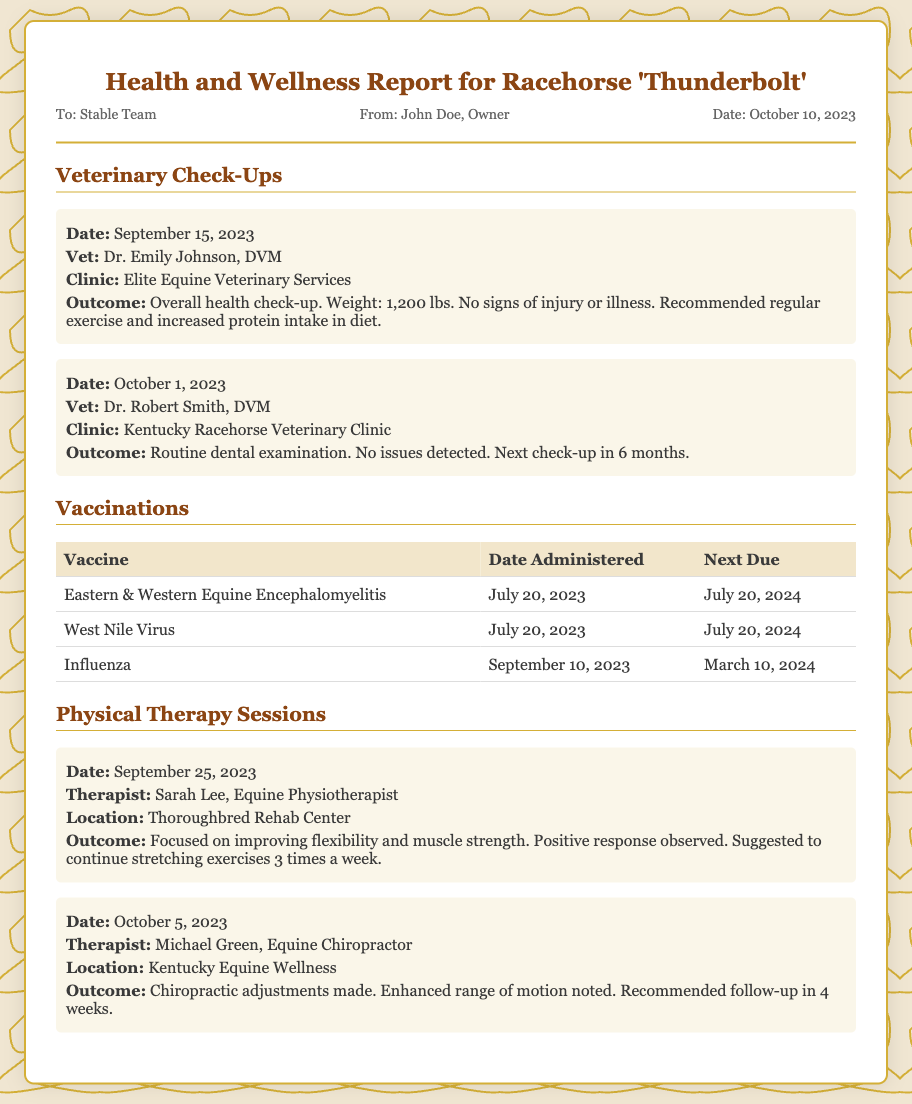What is the name of the racehorse? The document is focused on the health and wellness report for racehorse 'Thunderbolt'.
Answer: Thunderbolt Who is the veterinarian for the September 15, 2023 check-up? The document states that Dr. Emily Johnson, DVM conducted the check-up on September 15, 2023.
Answer: Dr. Emily Johnson What is the weight of Thunderbolt according to the check-up on September 15, 2023? The document mentions Thunderbolt's weight during the check-up was 1,200 lbs.
Answer: 1,200 lbs When is the next dental check-up scheduled? According to the report, the next dental check-up will be in 6 months after October 1, 2023.
Answer: April 1, 2024 How many vaccines were administered on July 20, 2023? The document lists two vaccines administered on that date: Eastern & Western Equine Encephalomyelitis and West Nile Virus.
Answer: Two What was the outcome of the physical therapy session on September 25, 2023? The document indicates that the focus was on improving flexibility and muscle strength, with a positive response observed.
Answer: Positive response Who conducted the chiropractic session on October 5, 2023? The document states that Michael Green, Equine Chiropractor, conducted the chiropractic adjustments.
Answer: Michael Green How often are stretching exercises recommended to continue after the therapy session? The report specifies that stretching exercises should continue 3 times a week.
Answer: 3 times a week What clinic conducted the routine dental examination? The document identifies Kentucky Racehorse Veterinary Clinic as the clinic for the dental examination.
Answer: Kentucky Racehorse Veterinary Clinic 